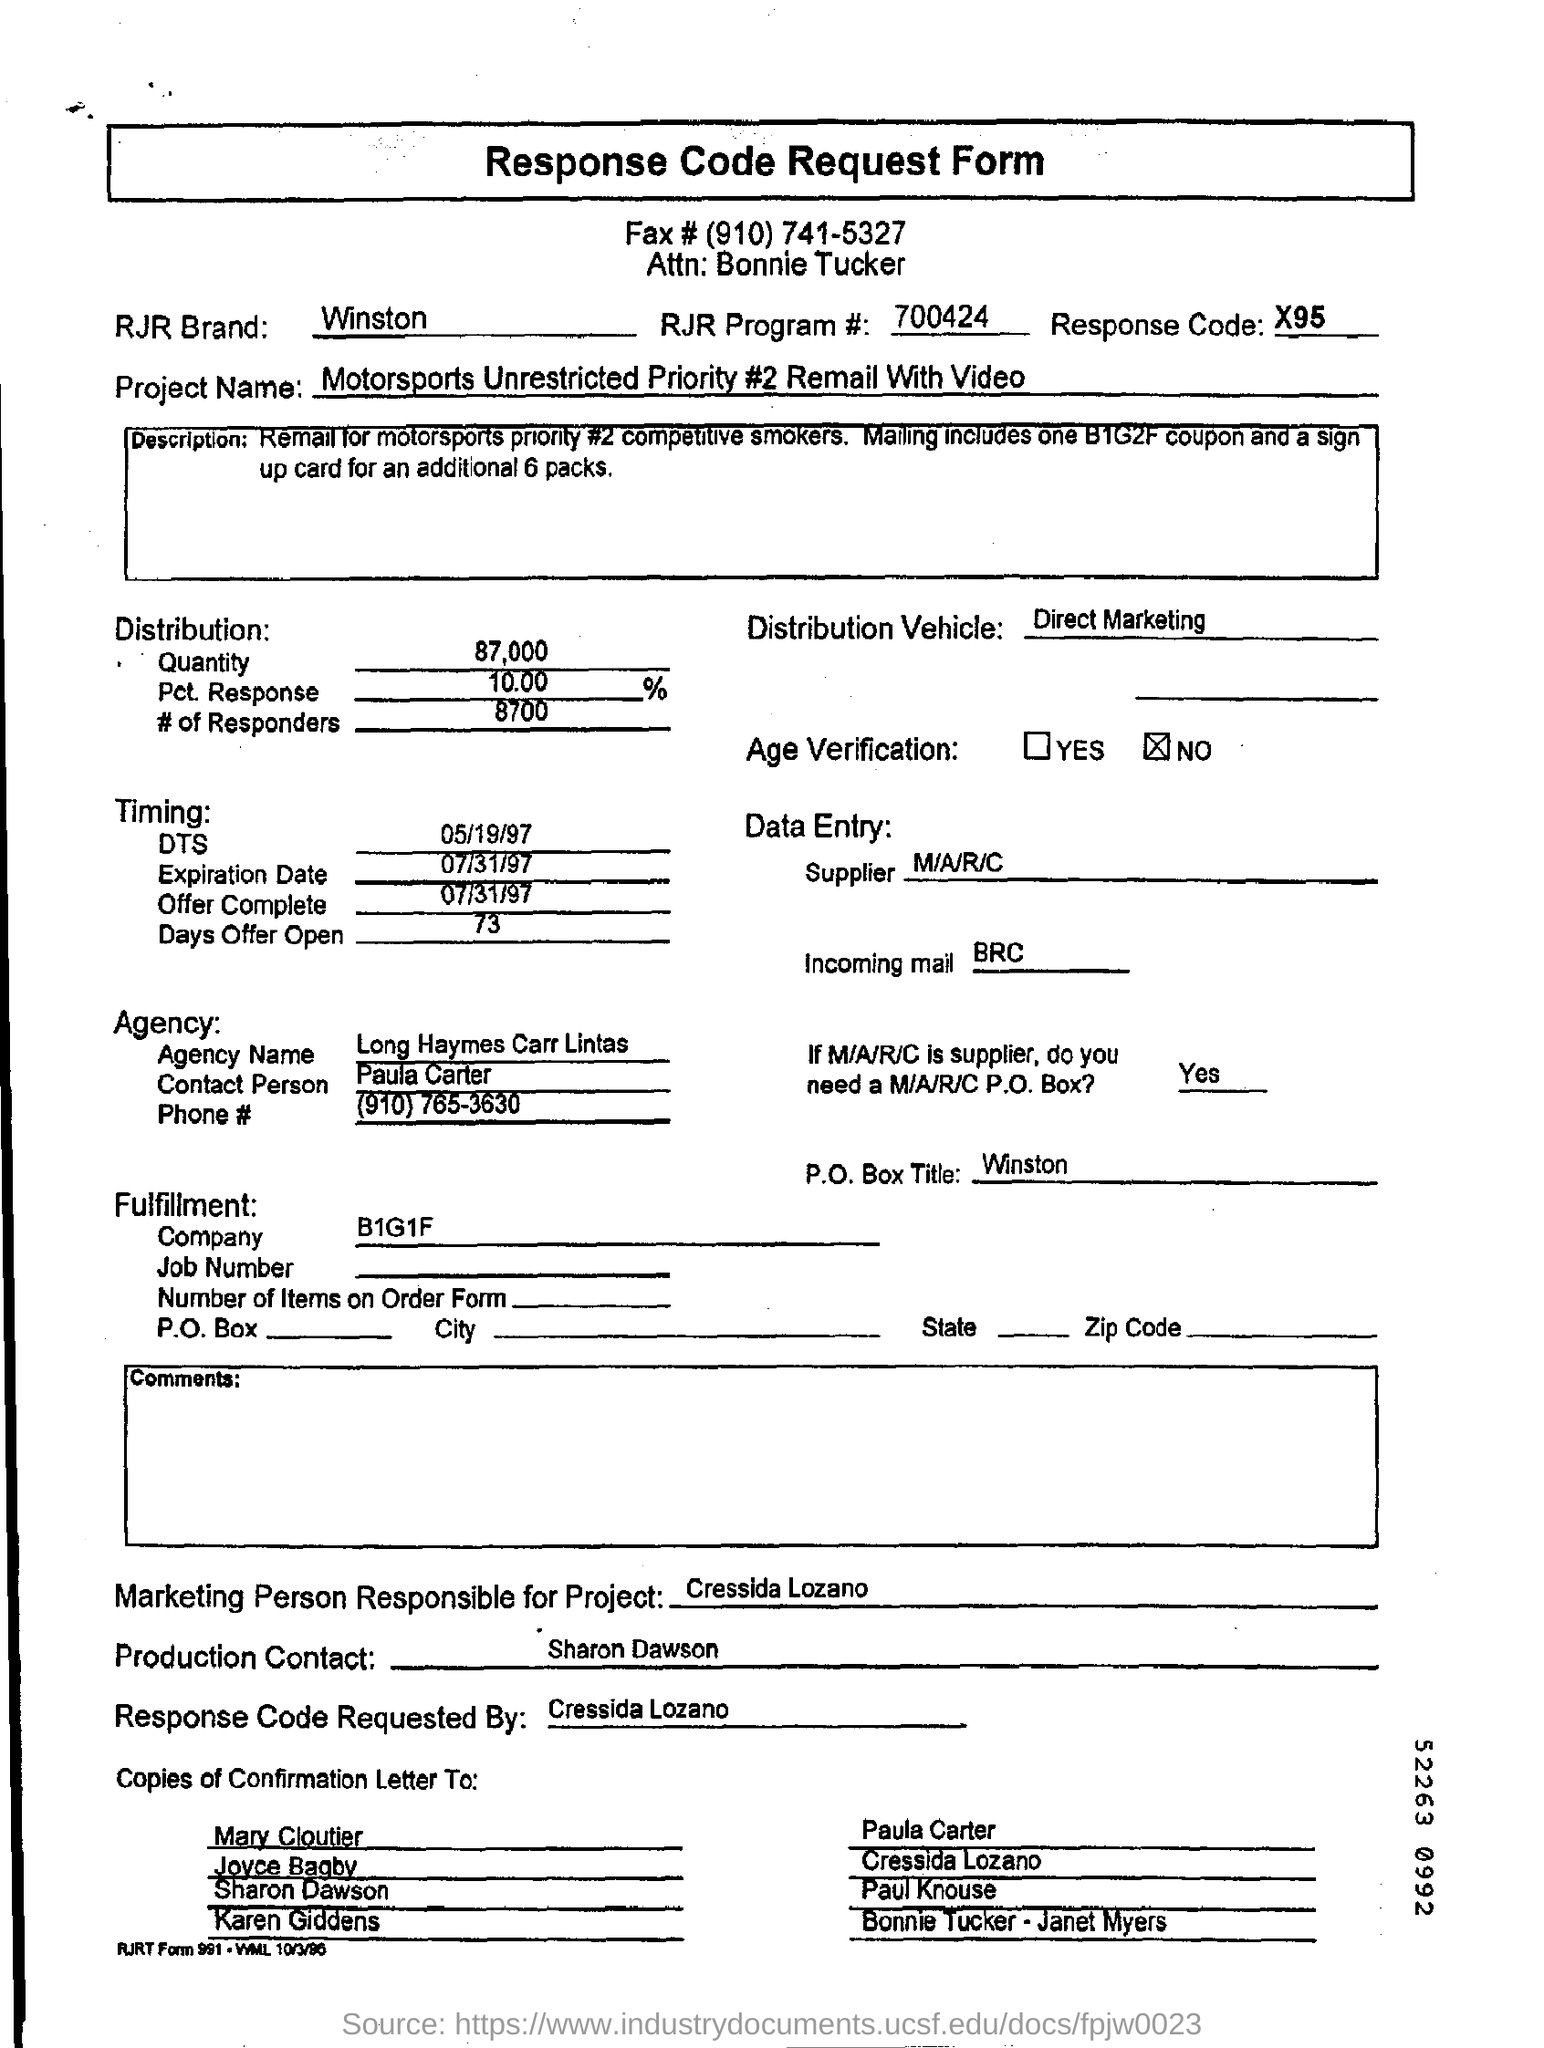What is the Title of the document ?
Give a very brief answer. Response Code Request Form. What is the Fax Number ?
Offer a very short reply. (910) 741-5327. What is the RJR Brand name ?
Offer a very short reply. Winston. What is the RJR Program Number ?
Ensure brevity in your answer.  700424. What is written in the Distribution Vehicle Field ?
Your response must be concise. Direct Marketing. What is the Expiration Date ?
Give a very brief answer. 07/31/97. What is the Company Name ?
Provide a short and direct response. B1G1F. What is the Agency Name ?
Offer a terse response. Long Haymes Carr Lintas. What is the Offer Complete Date in the Document ?
Offer a very short reply. 07/31/97. Who is the Supplier ?
Offer a very short reply. M/A/R/C. 